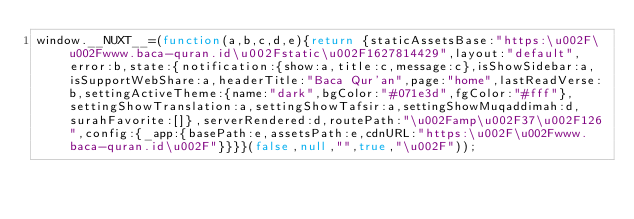Convert code to text. <code><loc_0><loc_0><loc_500><loc_500><_JavaScript_>window.__NUXT__=(function(a,b,c,d,e){return {staticAssetsBase:"https:\u002F\u002Fwww.baca-quran.id\u002Fstatic\u002F1627814429",layout:"default",error:b,state:{notification:{show:a,title:c,message:c},isShowSidebar:a,isSupportWebShare:a,headerTitle:"Baca Qur'an",page:"home",lastReadVerse:b,settingActiveTheme:{name:"dark",bgColor:"#071e3d",fgColor:"#fff"},settingShowTranslation:a,settingShowTafsir:a,settingShowMuqaddimah:d,surahFavorite:[]},serverRendered:d,routePath:"\u002Famp\u002F37\u002F126",config:{_app:{basePath:e,assetsPath:e,cdnURL:"https:\u002F\u002Fwww.baca-quran.id\u002F"}}}}(false,null,"",true,"\u002F"));</code> 